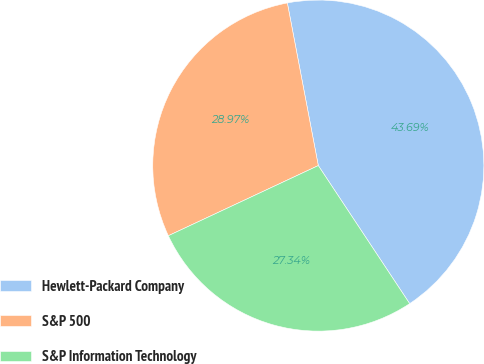Convert chart. <chart><loc_0><loc_0><loc_500><loc_500><pie_chart><fcel>Hewlett-Packard Company<fcel>S&P 500<fcel>S&P Information Technology<nl><fcel>43.69%<fcel>28.97%<fcel>27.34%<nl></chart> 